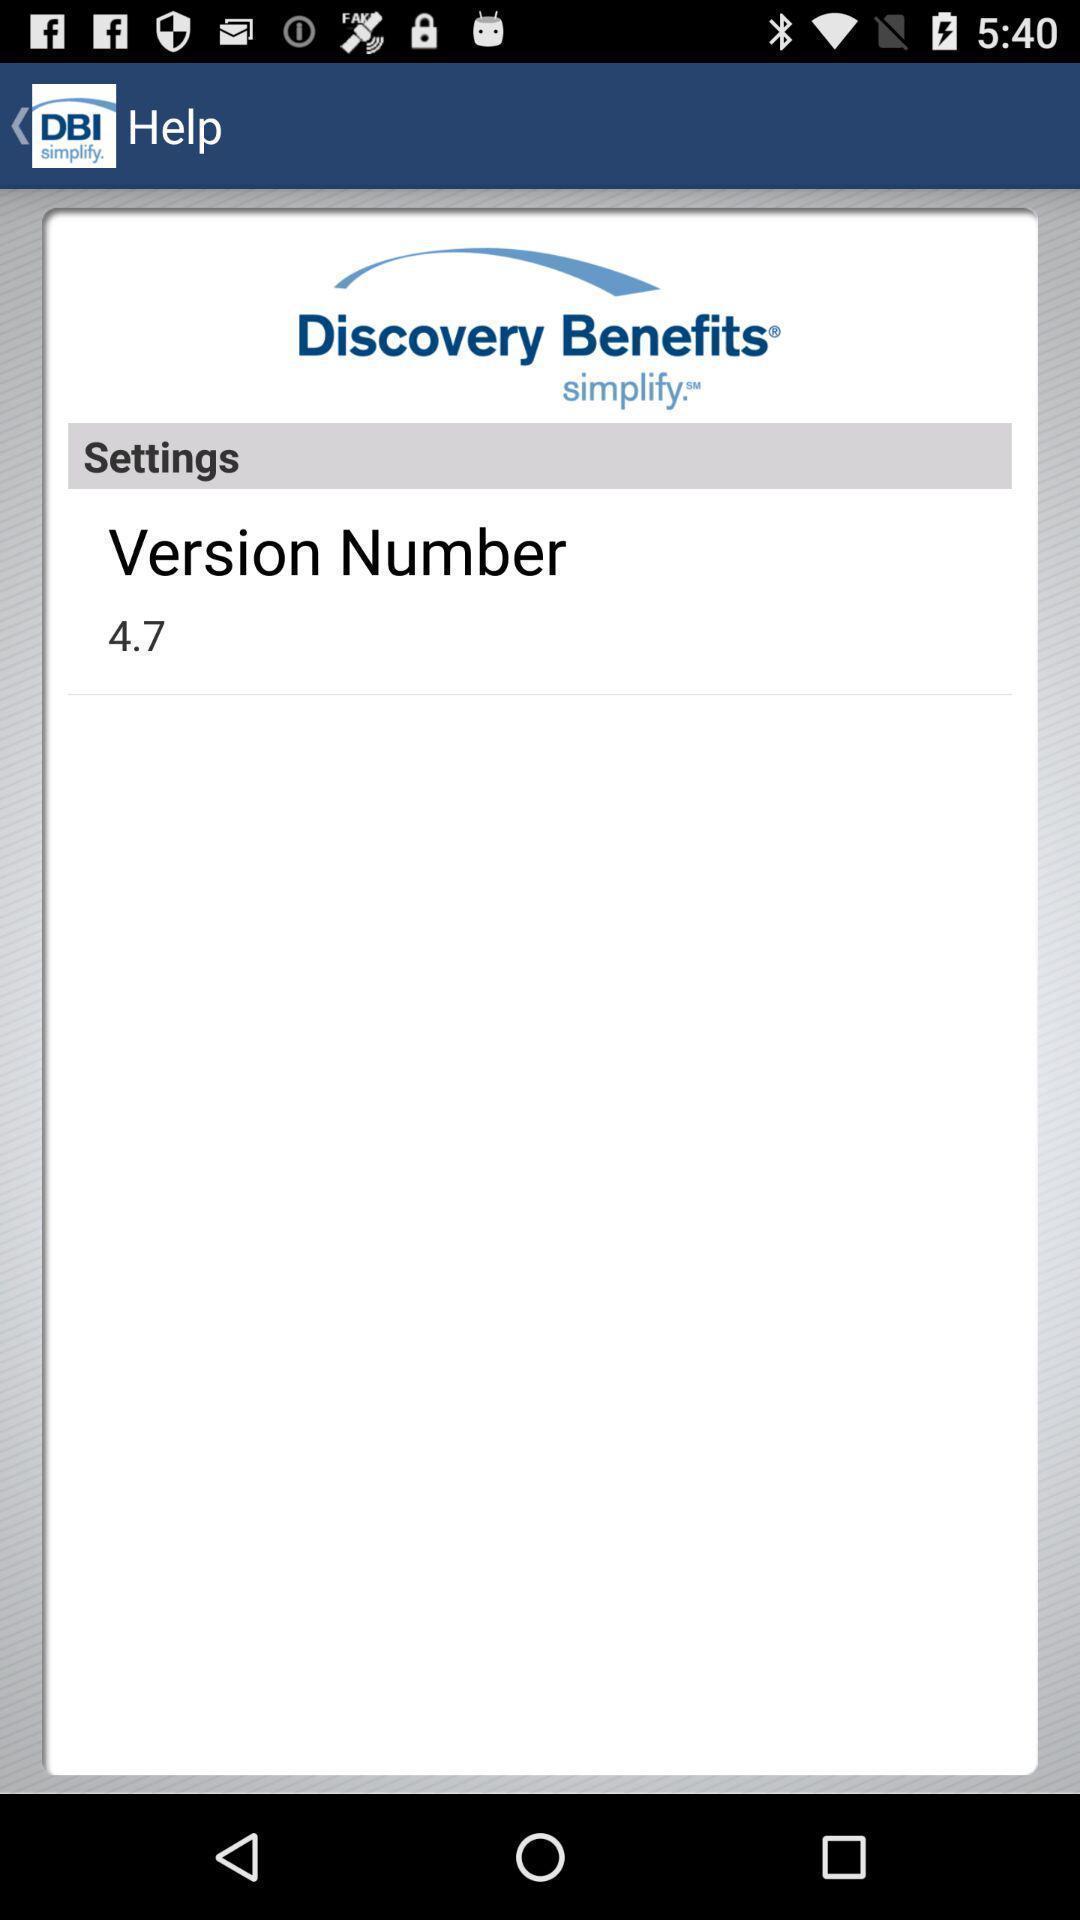Explain what's happening in this screen capture. Screen shows version number. 